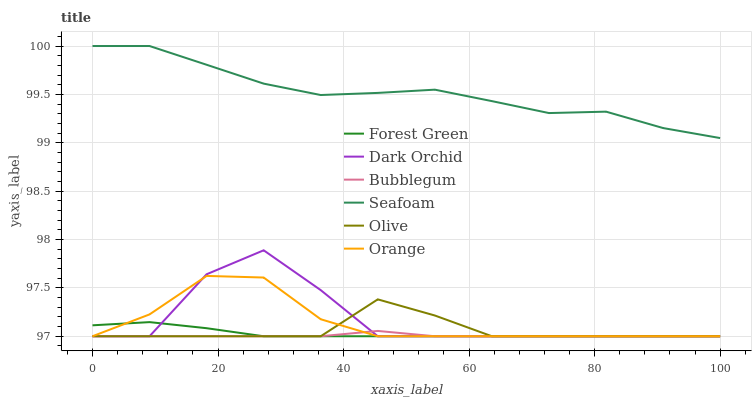Does Bubblegum have the minimum area under the curve?
Answer yes or no. Yes. Does Seafoam have the maximum area under the curve?
Answer yes or no. Yes. Does Orange have the minimum area under the curve?
Answer yes or no. No. Does Orange have the maximum area under the curve?
Answer yes or no. No. Is Forest Green the smoothest?
Answer yes or no. Yes. Is Dark Orchid the roughest?
Answer yes or no. Yes. Is Bubblegum the smoothest?
Answer yes or no. No. Is Bubblegum the roughest?
Answer yes or no. No. Does Seafoam have the highest value?
Answer yes or no. Yes. Does Orange have the highest value?
Answer yes or no. No. Is Orange less than Seafoam?
Answer yes or no. Yes. Is Seafoam greater than Orange?
Answer yes or no. Yes. Does Bubblegum intersect Orange?
Answer yes or no. Yes. Is Bubblegum less than Orange?
Answer yes or no. No. Is Bubblegum greater than Orange?
Answer yes or no. No. Does Orange intersect Seafoam?
Answer yes or no. No. 